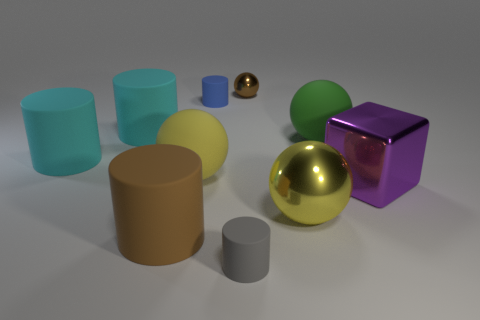What is the size of the brown matte object that is the same shape as the tiny blue matte object?
Offer a very short reply. Large. The big yellow thing that is to the right of the small gray cylinder has what shape?
Provide a short and direct response. Sphere. What is the color of the small matte object to the left of the tiny cylinder in front of the purple thing?
Offer a very short reply. Blue. How many objects are large rubber balls to the right of the blue cylinder or tiny blocks?
Your answer should be very brief. 1. There is a purple cube; is its size the same as the yellow thing that is to the left of the tiny gray cylinder?
Your answer should be very brief. Yes. What number of big things are green rubber spheres or brown things?
Your answer should be compact. 2. What is the shape of the brown rubber object?
Your answer should be compact. Cylinder. What size is the cylinder that is the same color as the small sphere?
Ensure brevity in your answer.  Large. Are there any gray objects that have the same material as the tiny gray cylinder?
Give a very brief answer. No. Are there more cyan metal blocks than large matte balls?
Provide a short and direct response. No. 